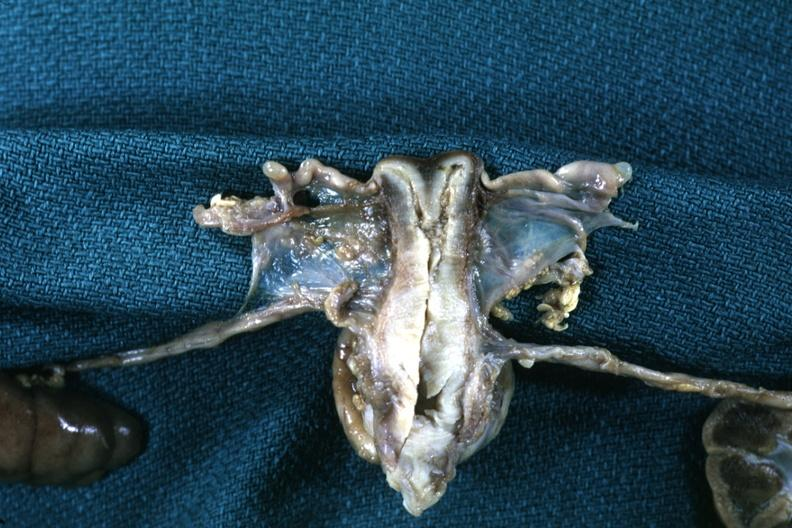what is present?
Answer the question using a single word or phrase. Female reproductive 